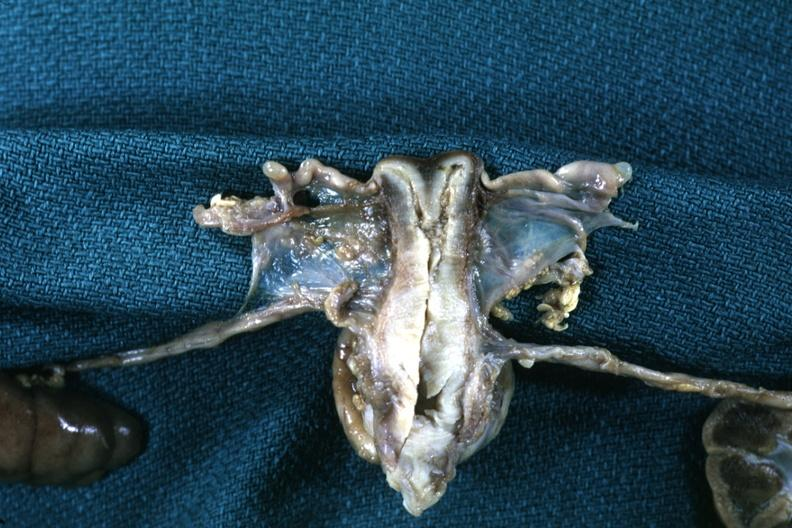what is present?
Answer the question using a single word or phrase. Female reproductive 